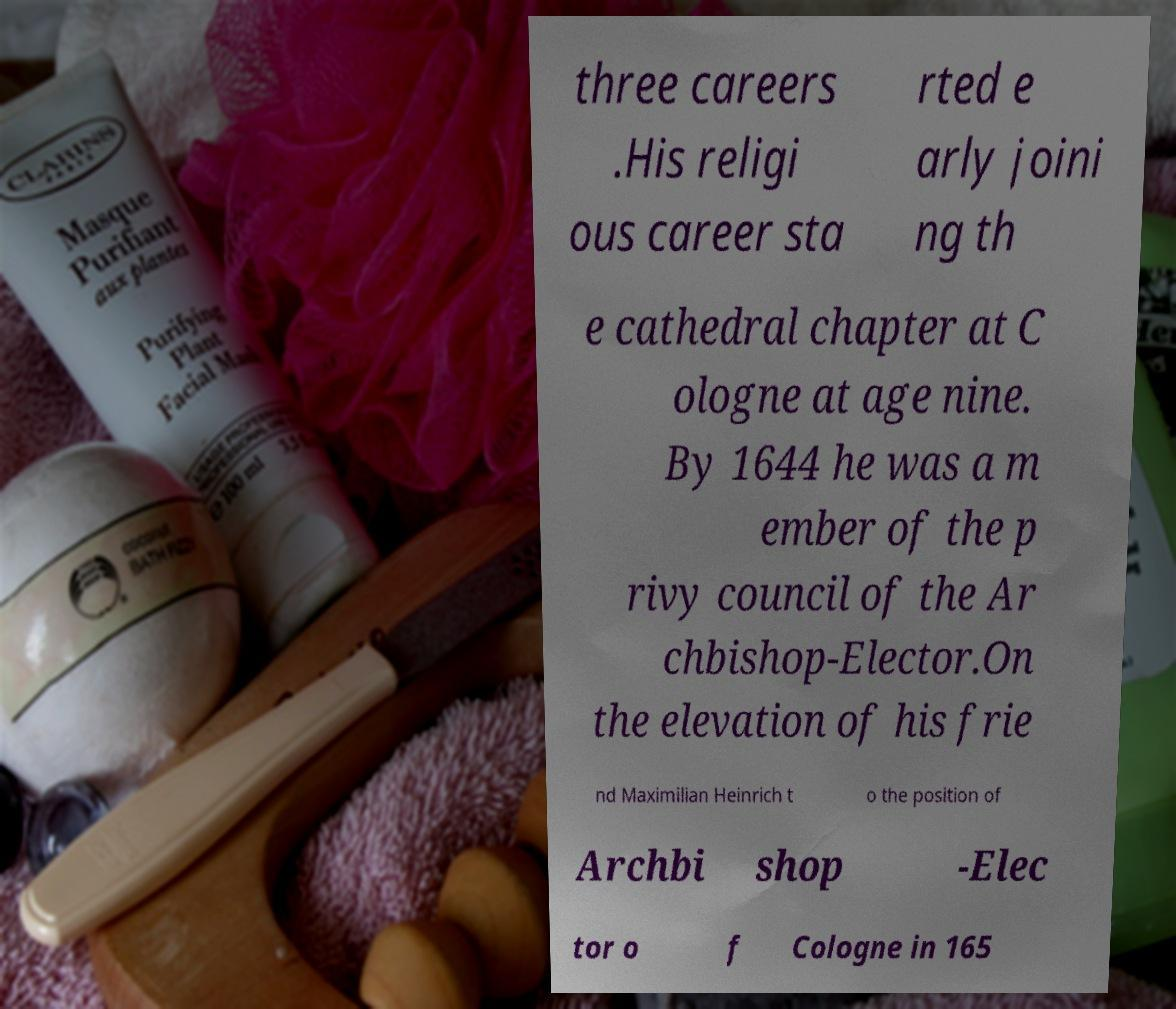I need the written content from this picture converted into text. Can you do that? three careers .His religi ous career sta rted e arly joini ng th e cathedral chapter at C ologne at age nine. By 1644 he was a m ember of the p rivy council of the Ar chbishop-Elector.On the elevation of his frie nd Maximilian Heinrich t o the position of Archbi shop -Elec tor o f Cologne in 165 